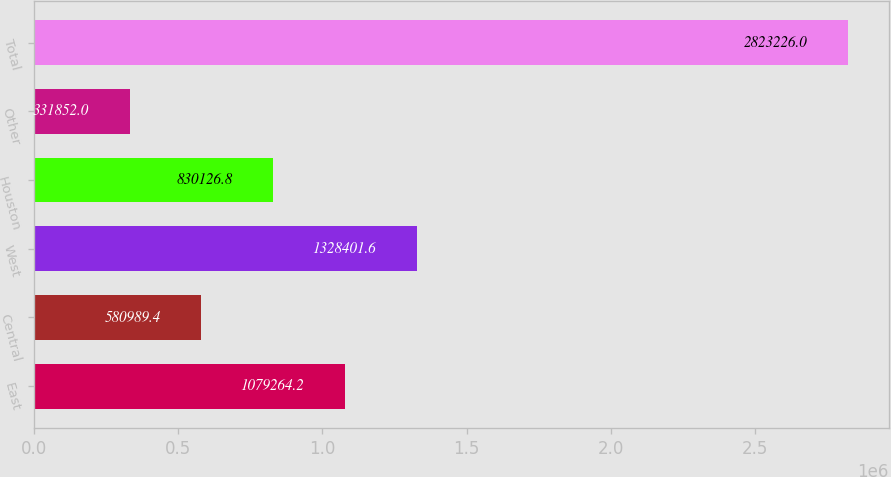Convert chart to OTSL. <chart><loc_0><loc_0><loc_500><loc_500><bar_chart><fcel>East<fcel>Central<fcel>West<fcel>Houston<fcel>Other<fcel>Total<nl><fcel>1.07926e+06<fcel>580989<fcel>1.3284e+06<fcel>830127<fcel>331852<fcel>2.82323e+06<nl></chart> 